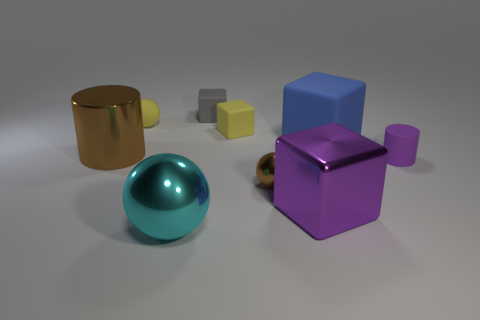Subtract all metallic spheres. How many spheres are left? 1 Add 1 large gray matte objects. How many objects exist? 10 Subtract 2 spheres. How many spheres are left? 1 Subtract all purple cubes. How many cubes are left? 3 Subtract all green spheres. Subtract all purple cubes. How many spheres are left? 3 Subtract 0 red cylinders. How many objects are left? 9 Subtract all cubes. How many objects are left? 5 Subtract all matte cylinders. Subtract all small gray rubber cubes. How many objects are left? 7 Add 5 cylinders. How many cylinders are left? 7 Add 8 tiny green matte spheres. How many tiny green matte spheres exist? 8 